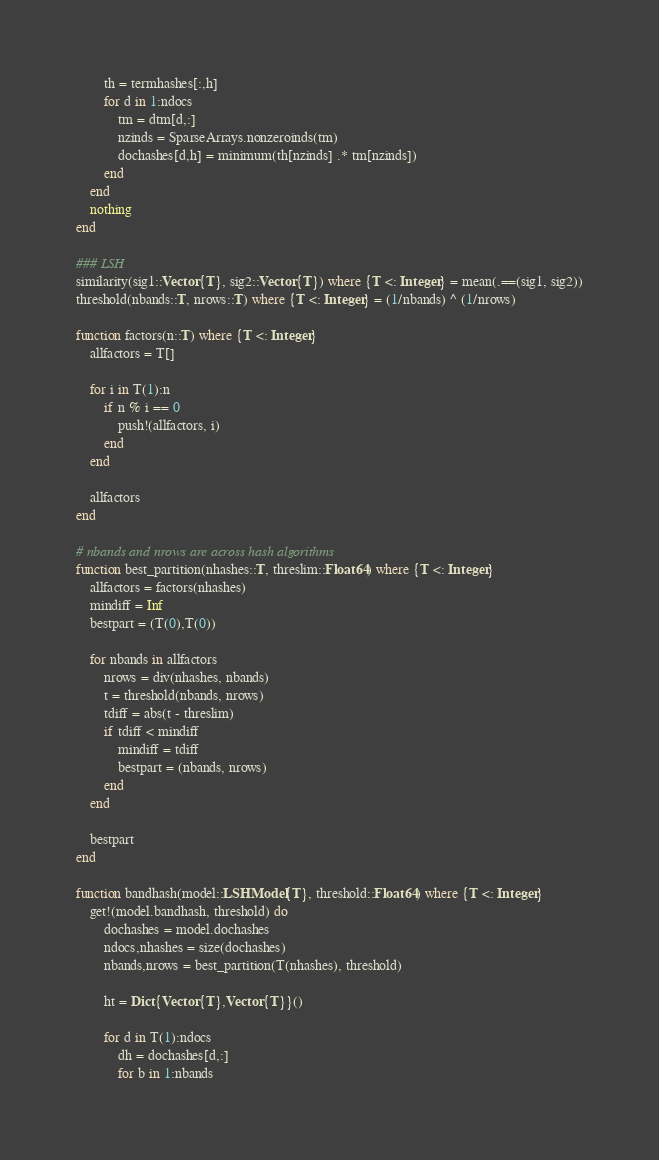<code> <loc_0><loc_0><loc_500><loc_500><_Julia_>        th = termhashes[:,h]
        for d in 1:ndocs
            tm = dtm[d,:]
            nzinds = SparseArrays.nonzeroinds(tm)
            dochashes[d,h] = minimum(th[nzinds] .* tm[nzinds])
        end
    end
    nothing
end

### LSH
similarity(sig1::Vector{T}, sig2::Vector{T}) where {T <: Integer} = mean(.==(sig1, sig2))
threshold(nbands::T, nrows::T) where {T <: Integer} = (1/nbands) ^ (1/nrows)

function factors(n::T) where {T <: Integer}
    allfactors = T[]

    for i in T(1):n
        if n % i == 0
            push!(allfactors, i)
        end
    end

    allfactors
end

# nbands and nrows are across hash algorithms
function best_partition(nhashes::T, threslim::Float64) where {T <: Integer}
    allfactors = factors(nhashes)
    mindiff = Inf
    bestpart = (T(0),T(0))

    for nbands in allfactors
        nrows = div(nhashes, nbands)
        t = threshold(nbands, nrows)
        tdiff = abs(t - threslim)
        if tdiff < mindiff
            mindiff = tdiff
            bestpart = (nbands, nrows)
        end
    end

    bestpart
end

function bandhash(model::LSHModel{T}, threshold::Float64) where {T <: Integer}
    get!(model.bandhash, threshold) do
        dochashes = model.dochashes
        ndocs,nhashes = size(dochashes)
        nbands,nrows = best_partition(T(nhashes), threshold)

        ht = Dict{Vector{T},Vector{T}}()

        for d in T(1):ndocs
            dh = dochashes[d,:]
            for b in 1:nbands</code> 